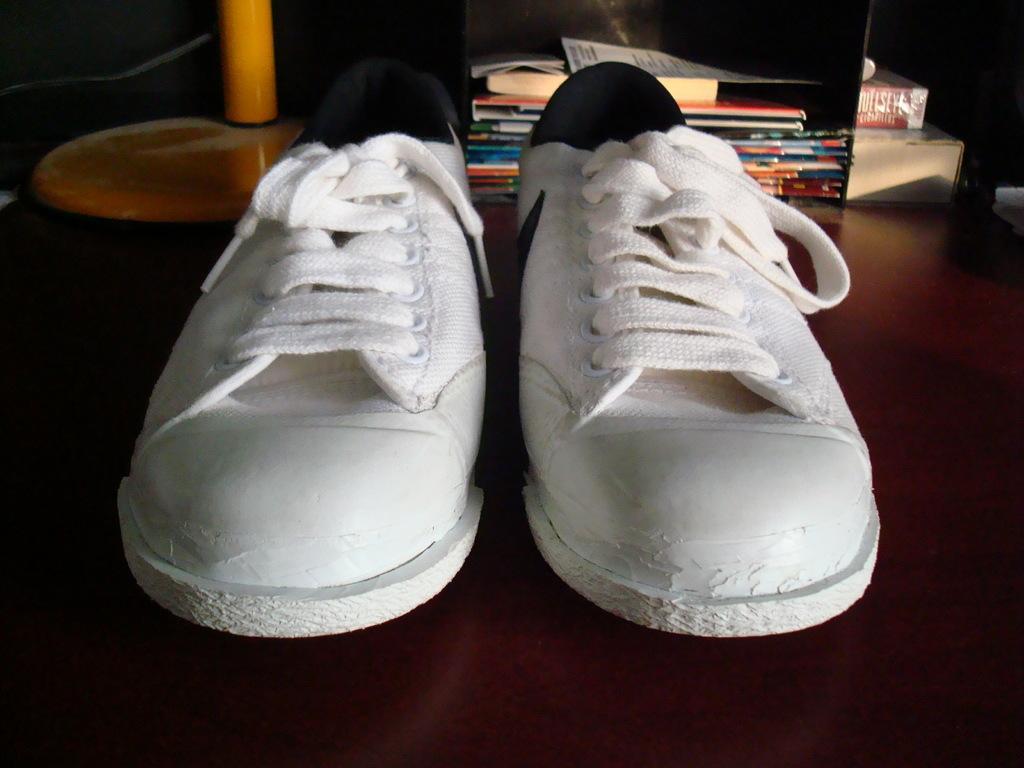In one or two sentences, can you explain what this image depicts? In this picture there is a pair of shoes which is in white color and there are few books and some other objects in the background. 